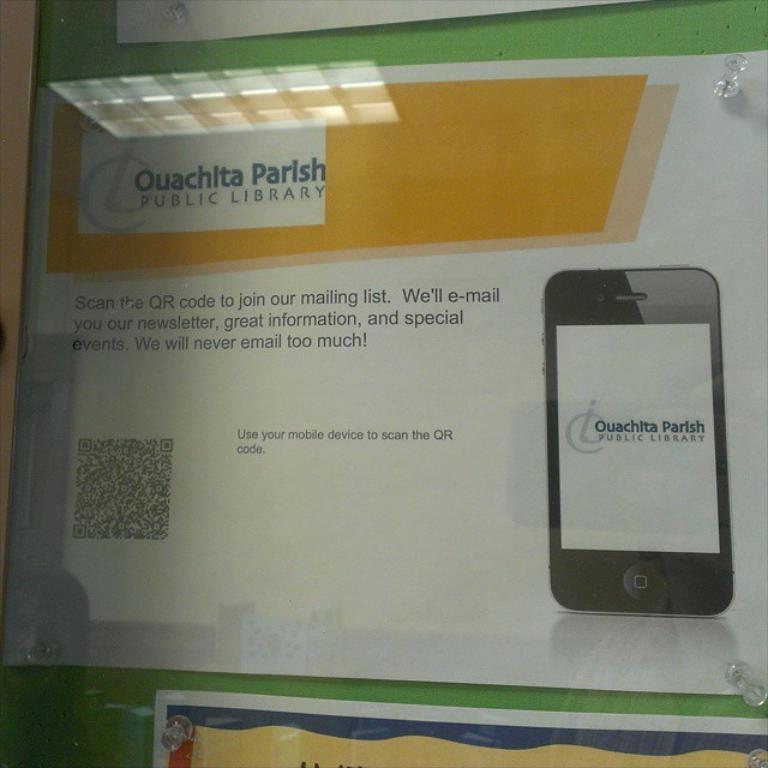<image>
Share a concise interpretation of the image provided. A poster asks people to scan the QR code to join the Ouachita Parish Public Library. 